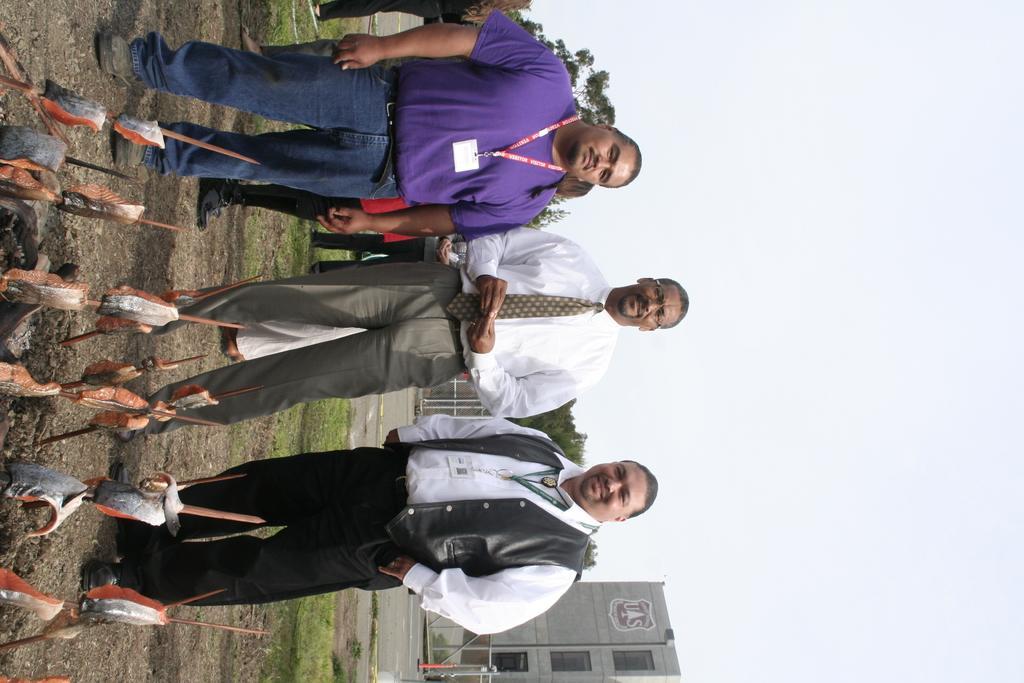Could you give a brief overview of what you see in this image? In this image we can see these three persons are standing on the ground. Here we can see some poles. In the background of the image we can see buildings, trees, fence and the sky. 